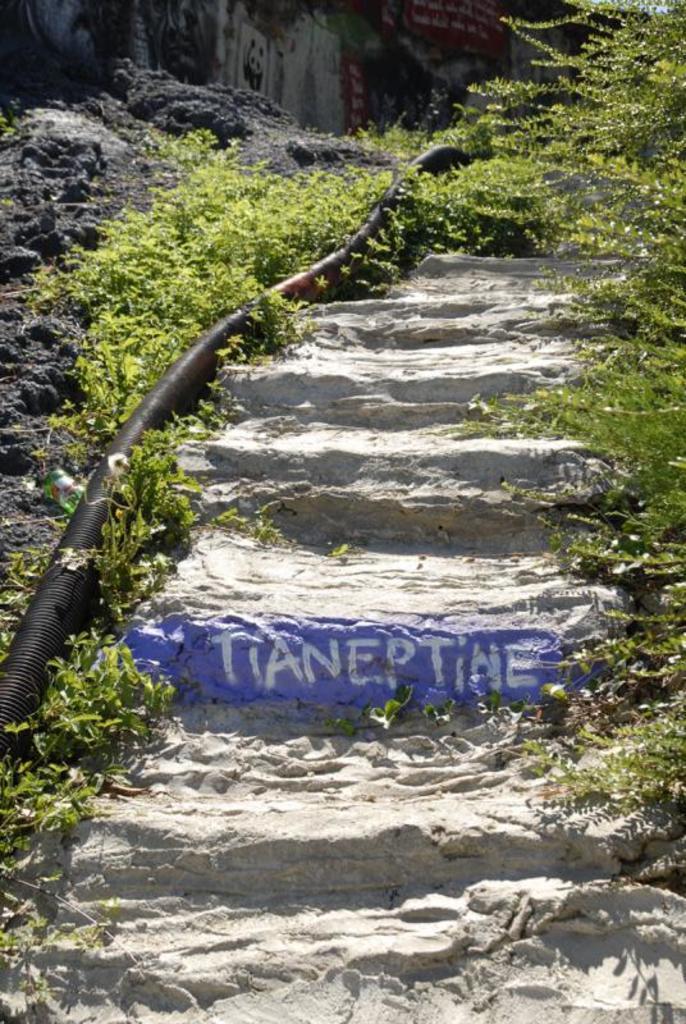Please provide a concise description of this image. In the picture I can see plants, steps and a black color pipe. 